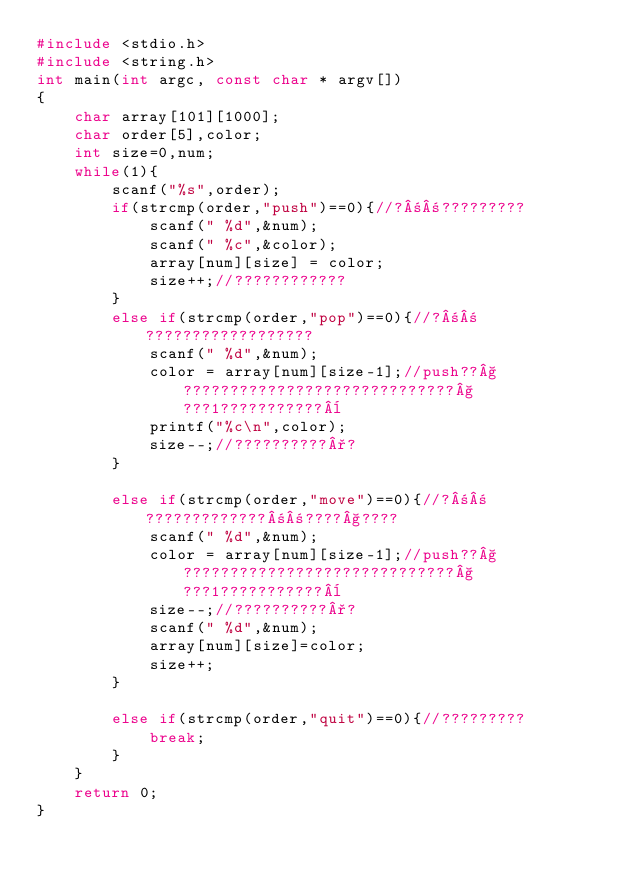Convert code to text. <code><loc_0><loc_0><loc_500><loc_500><_C_>#include <stdio.h>
#include <string.h>
int main(int argc, const char * argv[])
{
    char array[101][1000];
    char order[5],color;
    int size=0,num;
    while(1){
        scanf("%s",order);
        if(strcmp(order,"push")==0){//?±±?????????
            scanf(" %d",&num);
            scanf(" %c",&color);
            array[num][size] = color;
            size++;//????????????
        }
        else if(strcmp(order,"pop")==0){//?±±??????????????????
            scanf(" %d",&num);
            color = array[num][size-1];//push??§?????????????????????????????§???1???????????¨
            printf("%c\n",color);
            size--;//??????????°?
        }
        
        else if(strcmp(order,"move")==0){//?±±?????????????±±????§????
            scanf(" %d",&num);
            color = array[num][size-1];//push??§?????????????????????????????§???1???????????¨
            size--;//??????????°?
            scanf(" %d",&num);
            array[num][size]=color;
            size++;
        }
        
        else if(strcmp(order,"quit")==0){//?????????
            break;
        }
    }
    return 0;
}</code> 